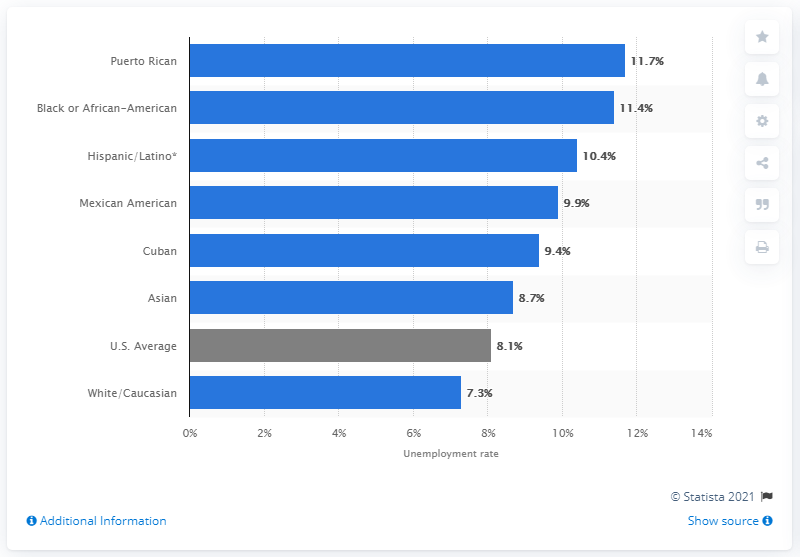Point out several critical features in this image. In 2020, the national unemployment rate was 8.1%. 